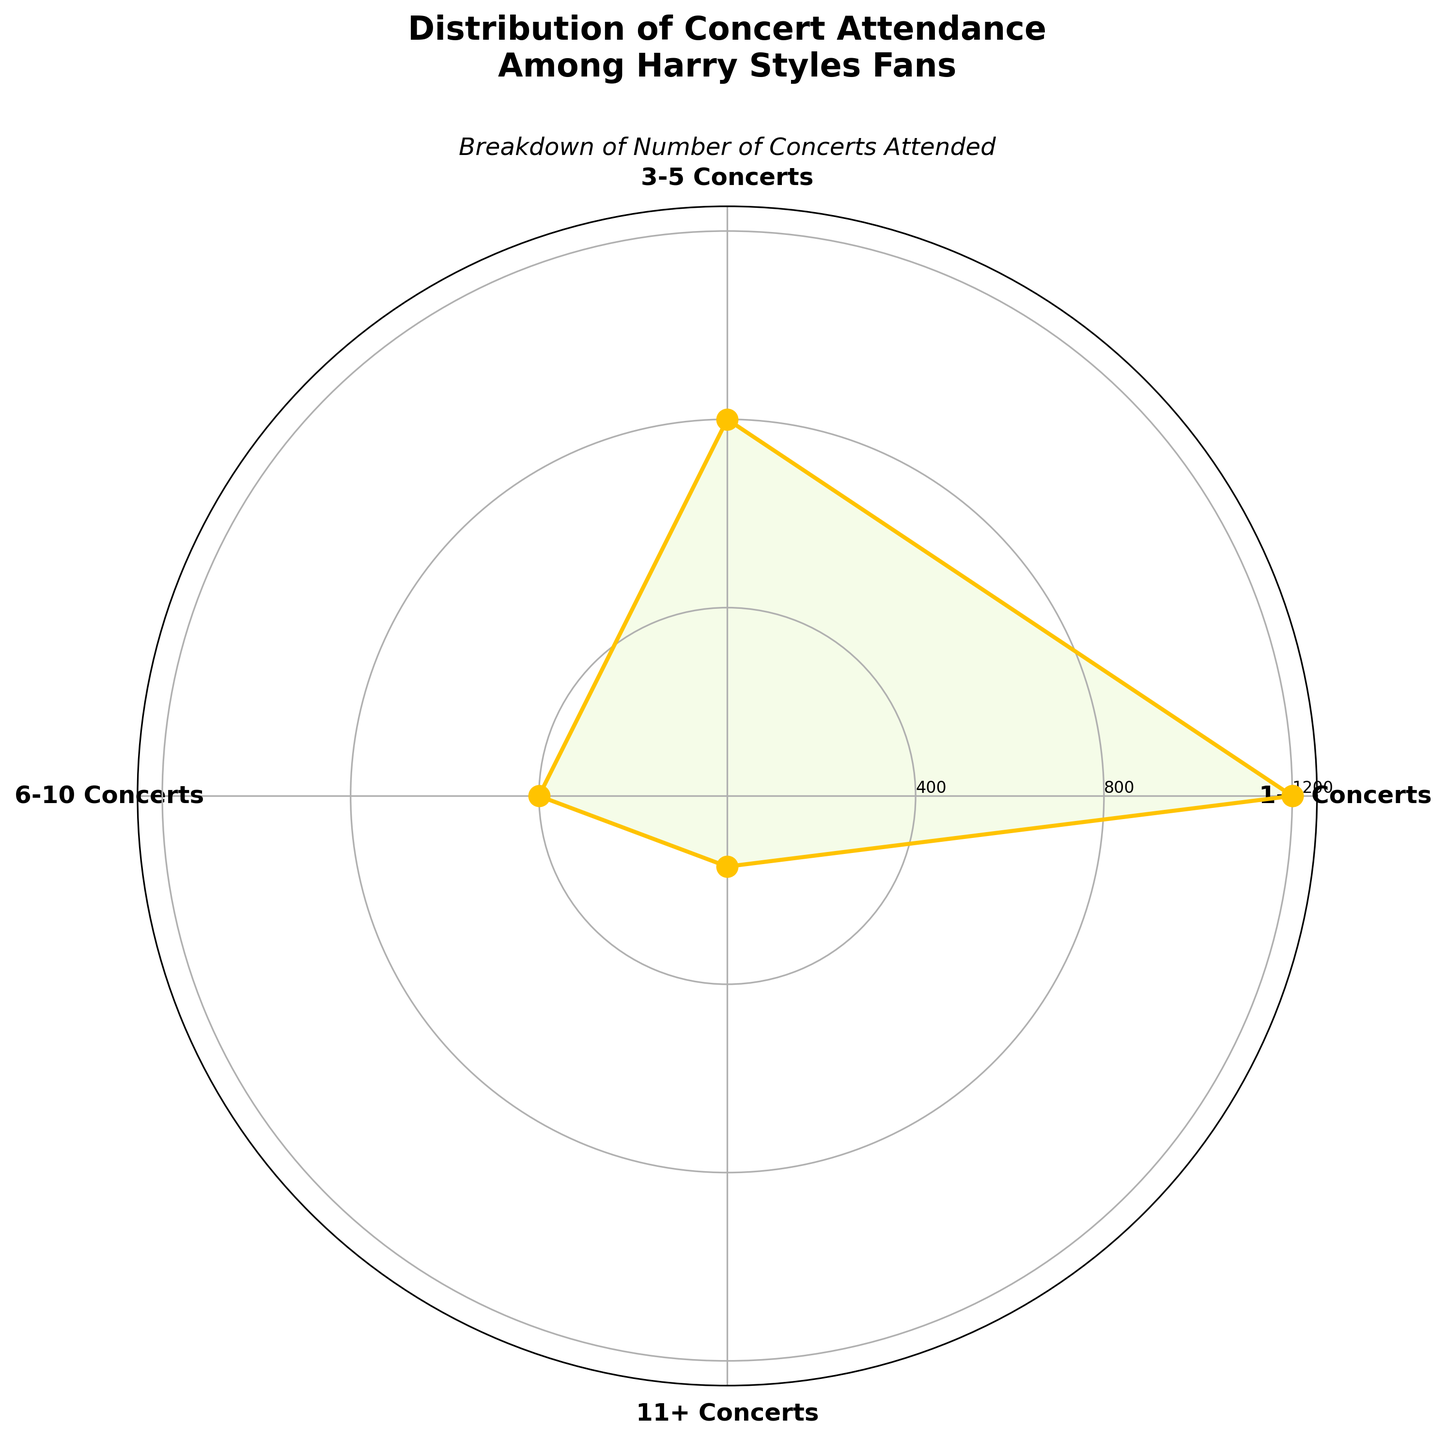How many concerts attended is the most common category among Harry Styles fans? The category with the highest number of fans is visually the tallest segment in the rose chart. Observing the lengths, "1-2 Concerts" is the highest.
Answer: 1-2 Concerts What is the total number of fans who attended more than 5 concerts? To get the total, sum up the fans for "6-10 Concerts" and "11+ Concerts." 400 + 150 = 550.
Answer: 550 Between the "3-5 Concerts" and "6-10 Concerts" categories, which has more fans attending? Compare the lengths of the segments. The "3-5 Concerts" segment is longer than "6-10 Concerts."
Answer: 3-5 Concerts How does the count for the "1-2 Concerts" category compare to all other categories combined? Sum the fans in all other categories: 800 + 400 + 150 = 1350. Compare this with the "1-2 Concerts" which has 1200. 1350 > 1200.
Answer: Less than What is the ratio of fans attending "1-2 Concerts" to "3-5 Concerts"? Divide the number in the "1-2 Concerts" category by the number in the "3-5 Concerts" category. 1200 / 800 = 1.5.
Answer: 1.5 Which category has the fewest fans attending Harry Styles concerts? Identify the visually smallest segment in the rose chart. "11+ Concerts" has the fewest fans.
Answer: 11+ Concerts What percentage of fans attended 3 or more concerts? Add fans in "3-5 Concerts," "6-10 Concerts," and "11+ Concerts": 800 + 400 + 150 = 1350. Divide by the total fans: 1350 / (1200 + 800 + 400 + 150) = 1350 / 2550 = 0.5294, multiply by 100 = 52.94%.
Answer: Approximately 52.94% Rank the categories by the number of fans in ascending order. Order the category fan counts from least to most: "11+ Concerts" (150), "6-10 Concerts" (400), "3-5 Concerts" (800), "1-2 Concerts" (1200).
Answer: 11+ Concerts, 6-10 Concerts, 3-5 Concerts, 1-2 Concerts 